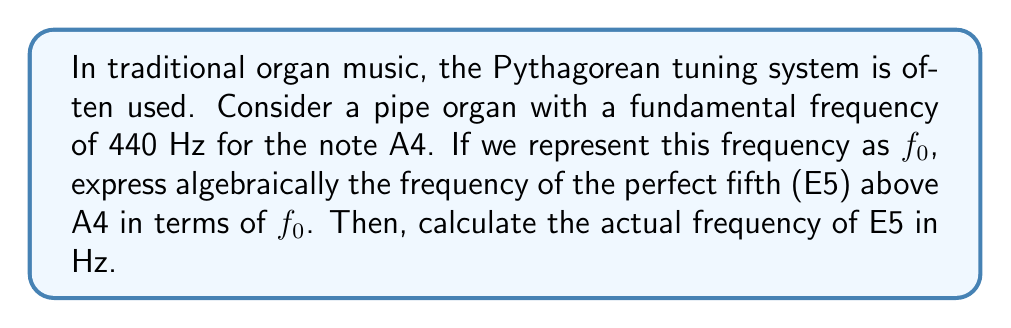What is the answer to this math problem? Let's approach this step-by-step:

1) In Pythagorean tuning, the ratio of frequencies for a perfect fifth is 3:2.

2) We can express this algebraically as:

   $$f_{\text{E5}} = f_0 \cdot \frac{3}{2}$$

   Where $f_{\text{E5}}$ is the frequency of E5 and $f_0$ is the frequency of A4.

3) We're given that $f_0 = 440$ Hz (A4).

4) To calculate the actual frequency of E5, we substitute this value:

   $$f_{\text{E5}} = 440 \cdot \frac{3}{2} = 660 \text{ Hz}$$

5) Therefore, in the Pythagorean tuning system used in traditional organ music, the frequency of E5 is 660 Hz.

This algebraic representation demonstrates the mathematical relationship between notes in the musical scale, which is crucial in understanding the harmonic structure of traditional organ music.
Answer: $f_{\text{E5}} = f_0 \cdot \frac{3}{2} = 660 \text{ Hz}$ 